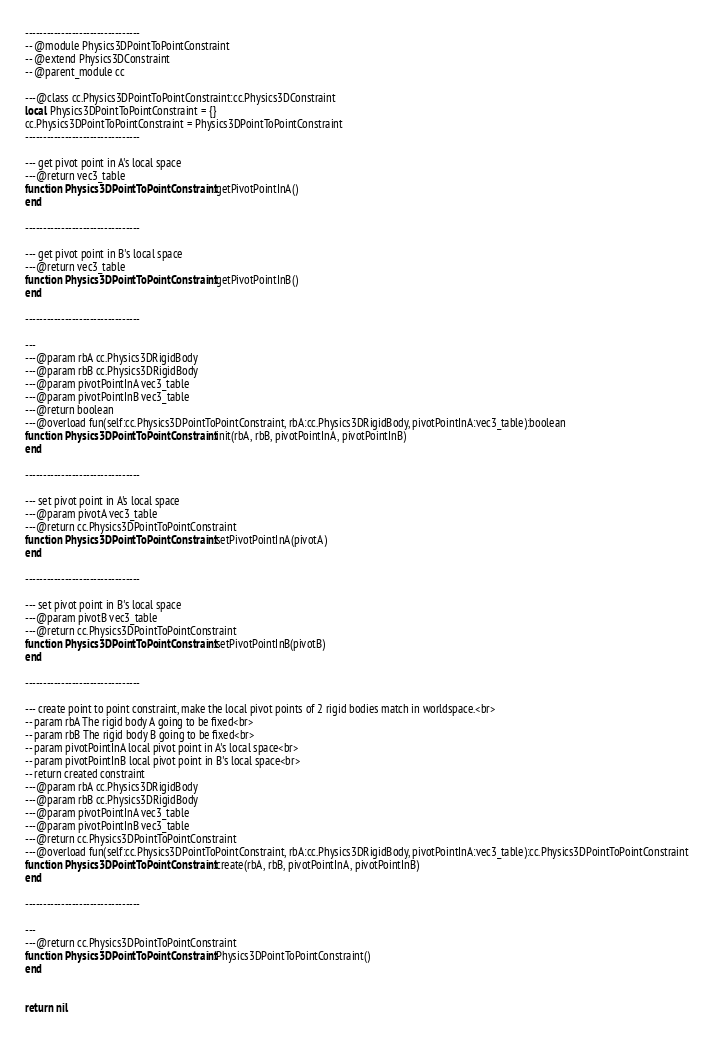Convert code to text. <code><loc_0><loc_0><loc_500><loc_500><_Lua_>
--------------------------------
-- @module Physics3DPointToPointConstraint
-- @extend Physics3DConstraint
-- @parent_module cc

---@class cc.Physics3DPointToPointConstraint:cc.Physics3DConstraint
local Physics3DPointToPointConstraint = {}
cc.Physics3DPointToPointConstraint = Physics3DPointToPointConstraint
--------------------------------

--- get pivot point in A's local space
---@return vec3_table
function Physics3DPointToPointConstraint:getPivotPointInA()
end

--------------------------------

--- get pivot point in B's local space
---@return vec3_table
function Physics3DPointToPointConstraint:getPivotPointInB()
end

--------------------------------

--- 
---@param rbA cc.Physics3DRigidBody
---@param rbB cc.Physics3DRigidBody
---@param pivotPointInA vec3_table
---@param pivotPointInB vec3_table
---@return boolean
---@overload fun(self:cc.Physics3DPointToPointConstraint, rbA:cc.Physics3DRigidBody, pivotPointInA:vec3_table):boolean
function Physics3DPointToPointConstraint:init(rbA, rbB, pivotPointInA, pivotPointInB)
end

--------------------------------

--- set pivot point in A's local space
---@param pivotA vec3_table
---@return cc.Physics3DPointToPointConstraint
function Physics3DPointToPointConstraint:setPivotPointInA(pivotA)
end

--------------------------------

--- set pivot point in B's local space
---@param pivotB vec3_table
---@return cc.Physics3DPointToPointConstraint
function Physics3DPointToPointConstraint:setPivotPointInB(pivotB)
end

--------------------------------

--- create point to point constraint, make the local pivot points of 2 rigid bodies match in worldspace.<br>
-- param rbA The rigid body A going to be fixed<br>
-- param rbB The rigid body B going to be fixed<br>
-- param pivotPointInA local pivot point in A's local space<br>
-- param pivotPointInB local pivot point in B's local space<br>
-- return created constraint
---@param rbA cc.Physics3DRigidBody
---@param rbB cc.Physics3DRigidBody
---@param pivotPointInA vec3_table
---@param pivotPointInB vec3_table
---@return cc.Physics3DPointToPointConstraint
---@overload fun(self:cc.Physics3DPointToPointConstraint, rbA:cc.Physics3DRigidBody, pivotPointInA:vec3_table):cc.Physics3DPointToPointConstraint
function Physics3DPointToPointConstraint:create(rbA, rbB, pivotPointInA, pivotPointInB)
end

--------------------------------

--- 
---@return cc.Physics3DPointToPointConstraint
function Physics3DPointToPointConstraint:Physics3DPointToPointConstraint()
end


return nil
</code> 